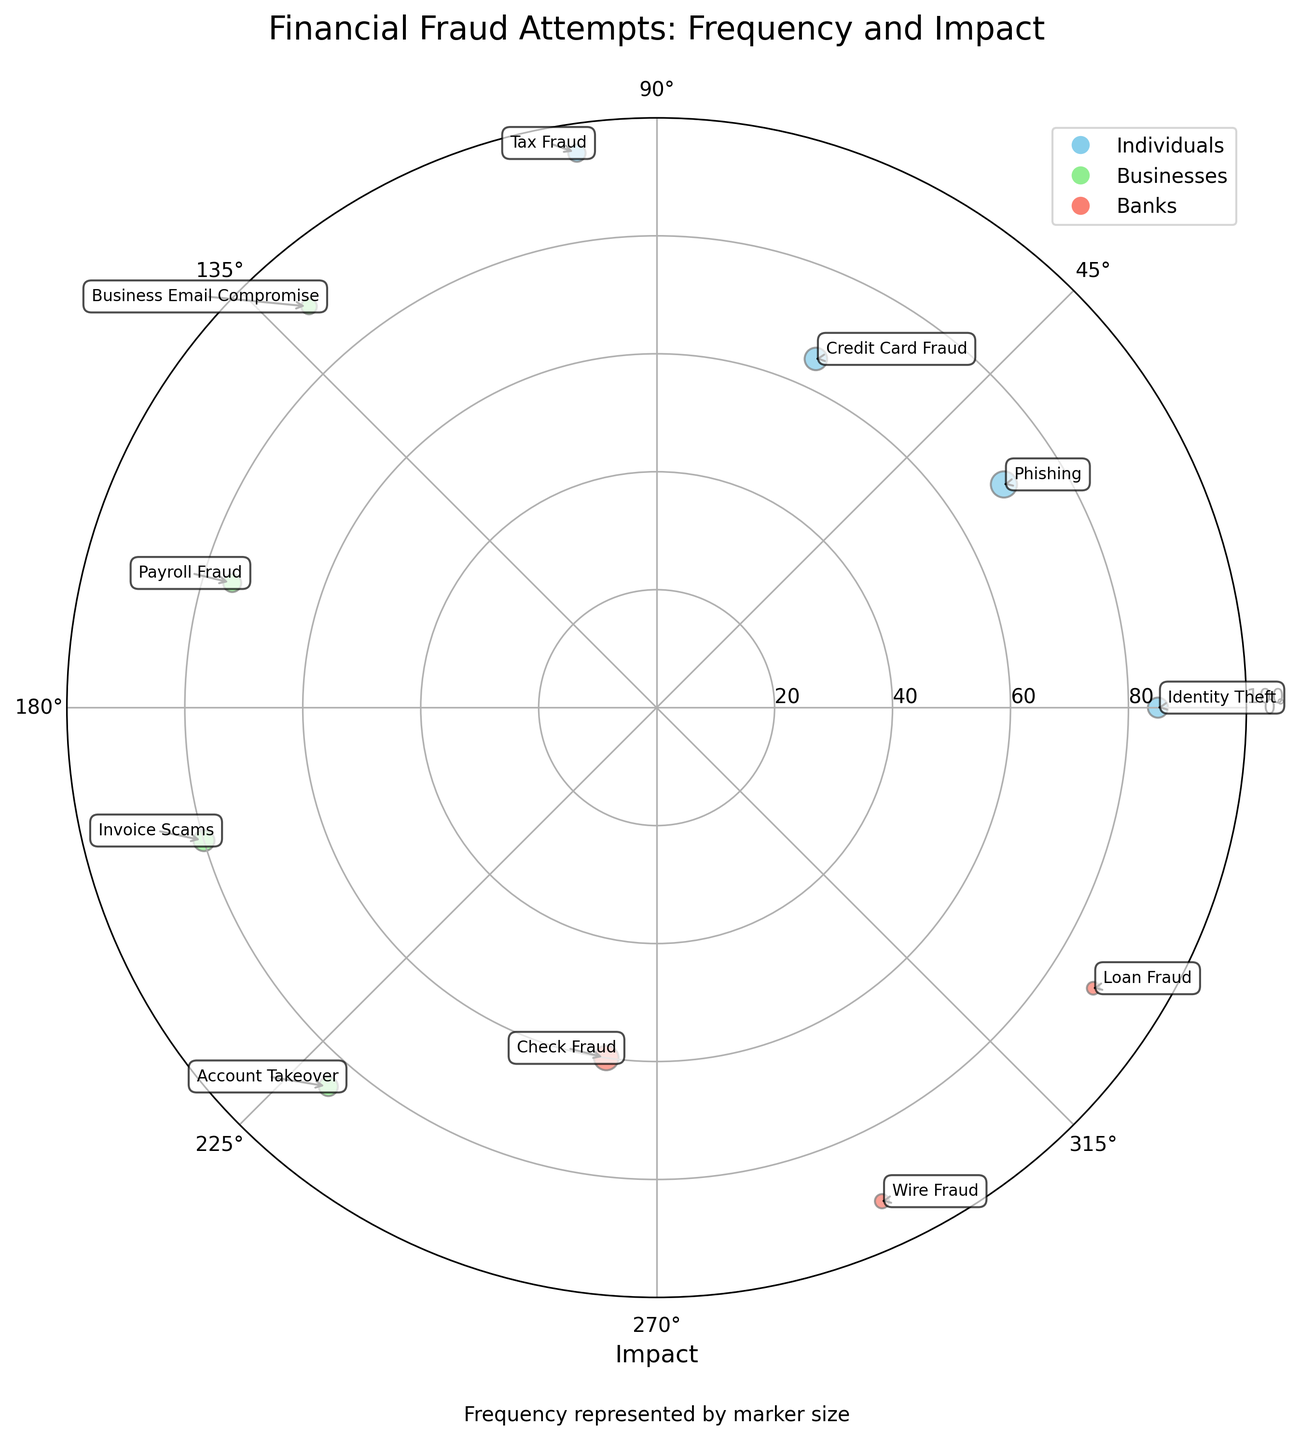What is the title of the figure? The title is prominently placed above the Polar Scatter Chart in a larger font size, indicating the central topic of the visual representation.
Answer: Financial Fraud Attempts: Frequency and Impact How many data points represent 'Businesses'? Look for data points colored in 'lightgreen', which denote 'Businesses'. There are 4 such data points.
Answer: 4 Which fraud type associated with 'Banks' has the lowest impact? Identify data points colored in 'salmon' for 'Banks'. Check the radial distance (impact) for each. The 'Loan Fraud' category is closest to the center.
Answer: Loan Fraud What color represents 'Individuals'? Locate the data points related to 'Individuals' in the legend or chart. They are colored 'skyblue'.
Answer: skyblue What's the largest frequency value and which fraud type does it correspond to? Identify the largest marker size on the plot, representing the highest frequency. Cross-reference it with the annotated fraud type. The largest marker corresponds to 'Phishing'.
Answer: 34, Phishing Which fraud type has the highest impact and how often does it occur? Look for the data point farthest from the center, indicating the highest impact. Annotate its corresponding fraud type and size for frequency. The 'Tax Fraud' type is farthest.
Answer: Tax Fraud, 15 Compare 'Business Email Compromise' and 'Identity Theft'. Which has a higher impact? Locate the annotations for both fraud types on the plot. Check their respective radial distances (impact). 'Business Email Compromise' is further out than 'Identity Theft'.
Answer: Business Email Compromise What is the average impact of fraud attempts in the 'Banks' category? Find the 'Banks' data points in 'salmon' (Check Fraud, Wire Fraud, Loan Fraud). Calculate the mean impact: (60 + 92 + 88) / 3 = 80.
Answer: 80 Which fraud type has the closest impact to 80 and how frequent is it? Scan the radial positions for the value closest to 80. 'Invoice Scams' falls at 80. Check the marker size for frequency.
Answer: Invoice Scams, 22 Do ‘Credit Card Fraud’ or ‘Payroll Fraud’ have more occurrences? Compare the marker sizes associated with 'Credit Card Fraud' and 'Payroll Fraud'. 'Credit Card Fraud' has a larger size.
Answer: Credit Card Fraud 